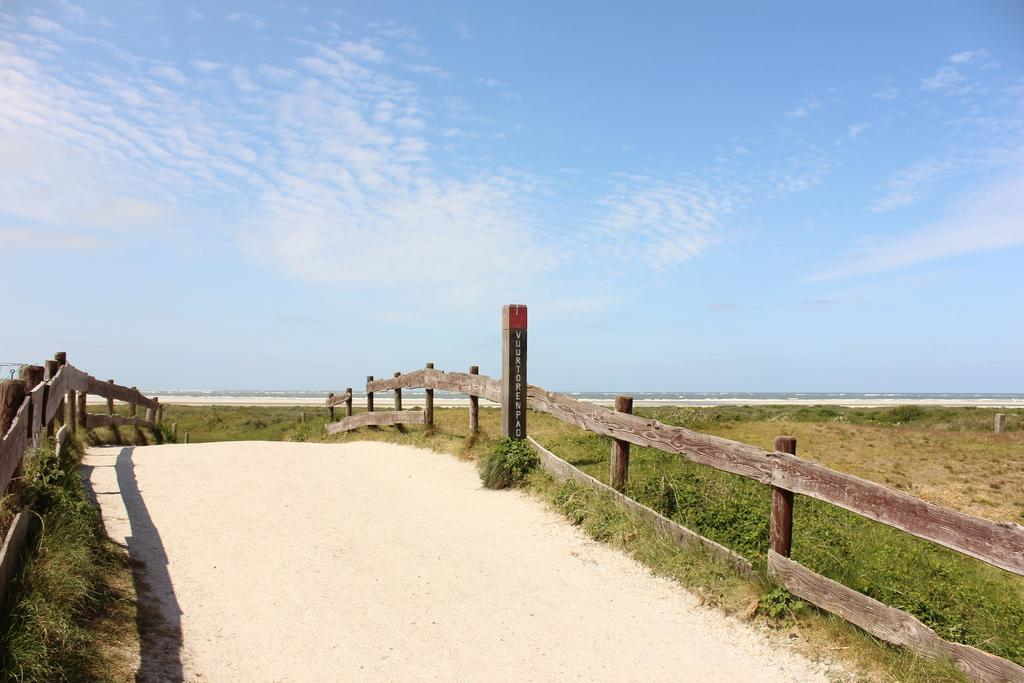What type of surface can be seen in the image? There is a path in the image. What is located alongside the path? There is a fence in the image. What type of vegetation is present in the image? There is grass in the image. What can be seen in the background of the image? The sky is visible in the background of the image. What is the condition of the sky in the image? Clouds are present in the sky. What type of nerve can be seen in the image? There is no nerve present in the image. Can you tell me how many times the image turns around? The image does not turn around; it is a static representation. 